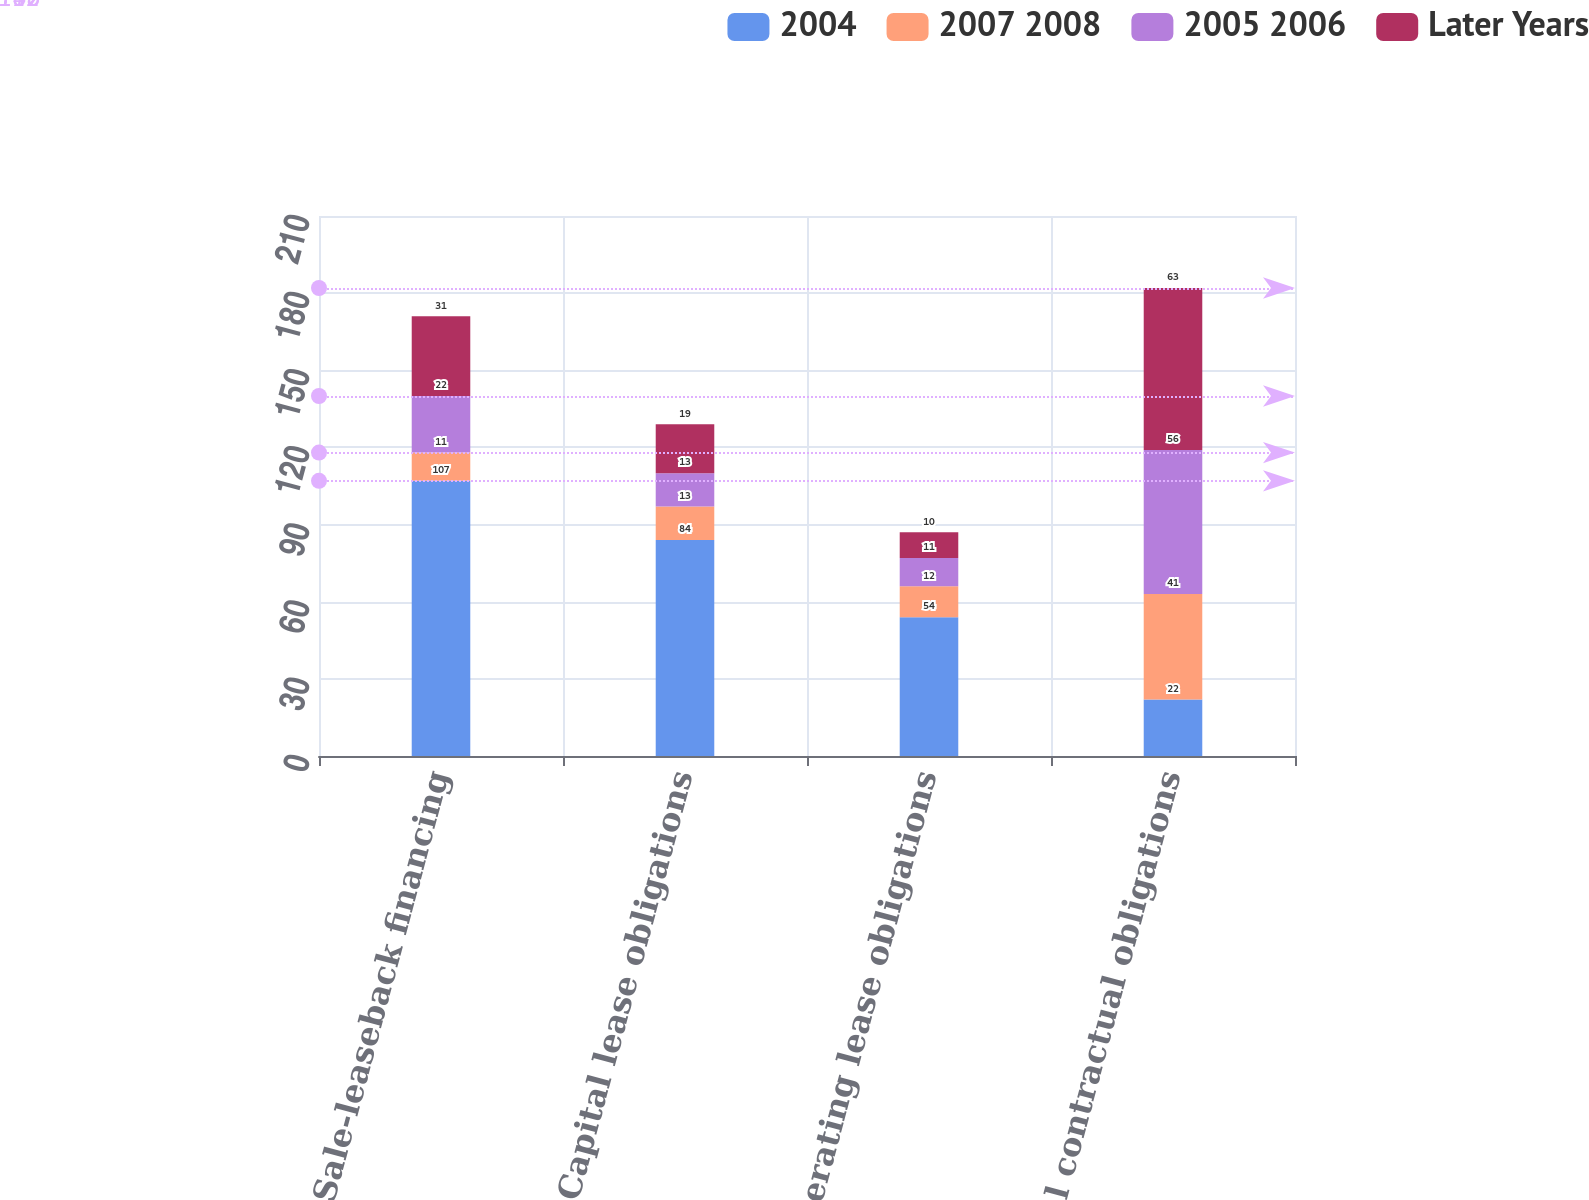Convert chart. <chart><loc_0><loc_0><loc_500><loc_500><stacked_bar_chart><ecel><fcel>Sale-leaseback financing<fcel>Capital lease obligations<fcel>Operating lease obligations<fcel>Total contractual obligations<nl><fcel>2004<fcel>107<fcel>84<fcel>54<fcel>22<nl><fcel>2007 2008<fcel>11<fcel>13<fcel>12<fcel>41<nl><fcel>2005 2006<fcel>22<fcel>13<fcel>11<fcel>56<nl><fcel>Later Years<fcel>31<fcel>19<fcel>10<fcel>63<nl></chart> 